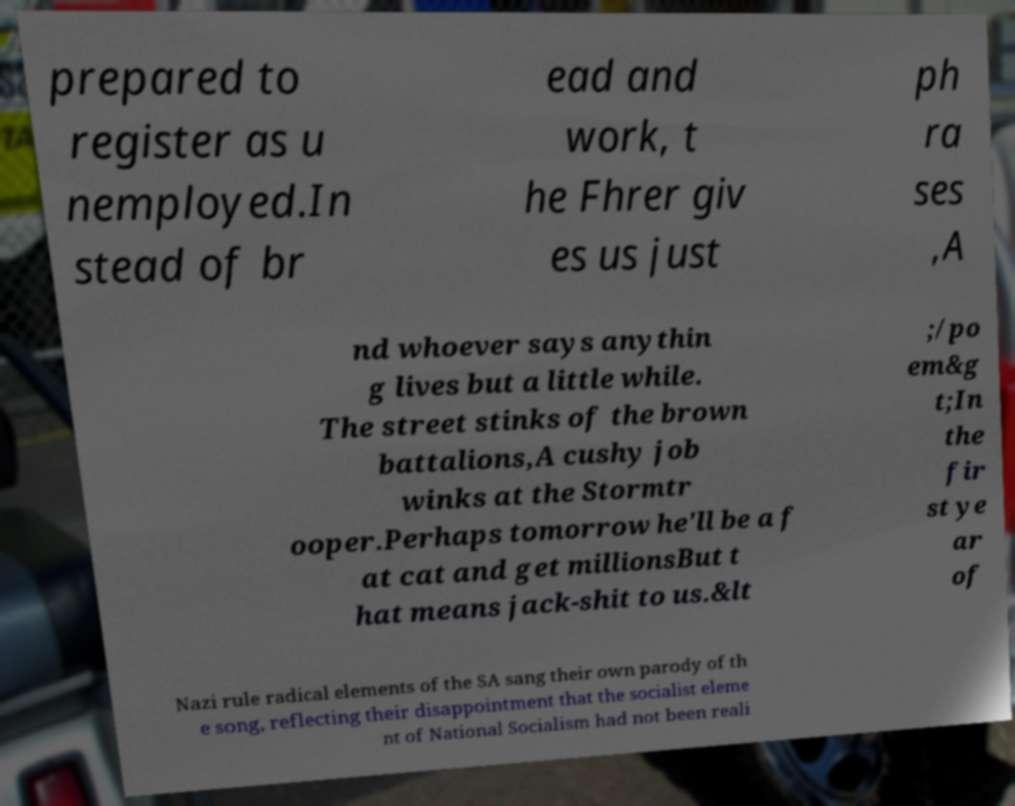There's text embedded in this image that I need extracted. Can you transcribe it verbatim? prepared to register as u nemployed.In stead of br ead and work, t he Fhrer giv es us just ph ra ses ,A nd whoever says anythin g lives but a little while. The street stinks of the brown battalions,A cushy job winks at the Stormtr ooper.Perhaps tomorrow he'll be a f at cat and get millionsBut t hat means jack-shit to us.&lt ;/po em&g t;In the fir st ye ar of Nazi rule radical elements of the SA sang their own parody of th e song, reflecting their disappointment that the socialist eleme nt of National Socialism had not been reali 